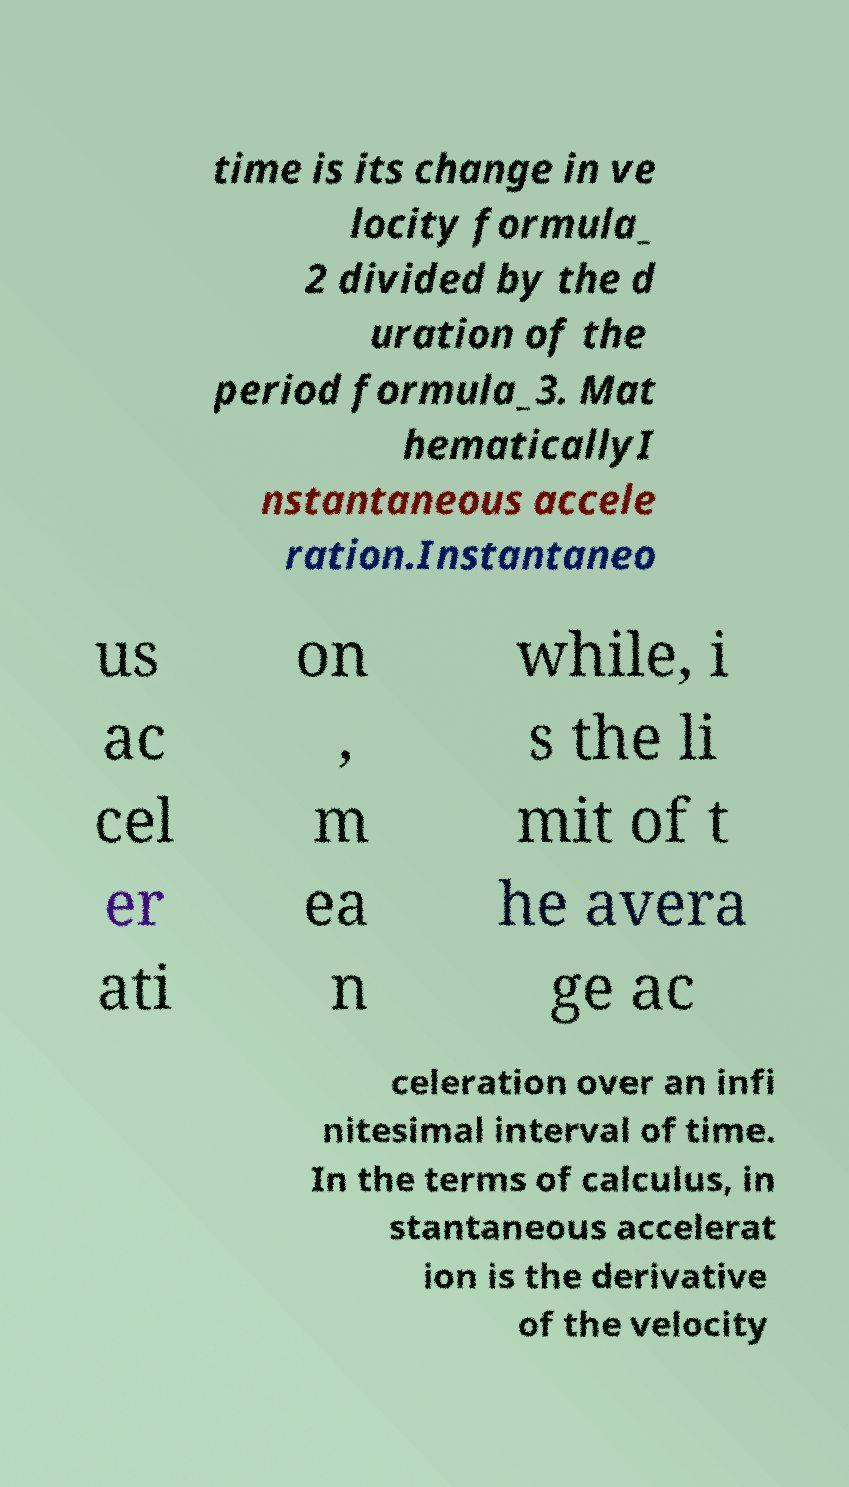What messages or text are displayed in this image? I need them in a readable, typed format. time is its change in ve locity formula_ 2 divided by the d uration of the period formula_3. Mat hematicallyI nstantaneous accele ration.Instantaneo us ac cel er ati on , m ea n while, i s the li mit of t he avera ge ac celeration over an infi nitesimal interval of time. In the terms of calculus, in stantaneous accelerat ion is the derivative of the velocity 